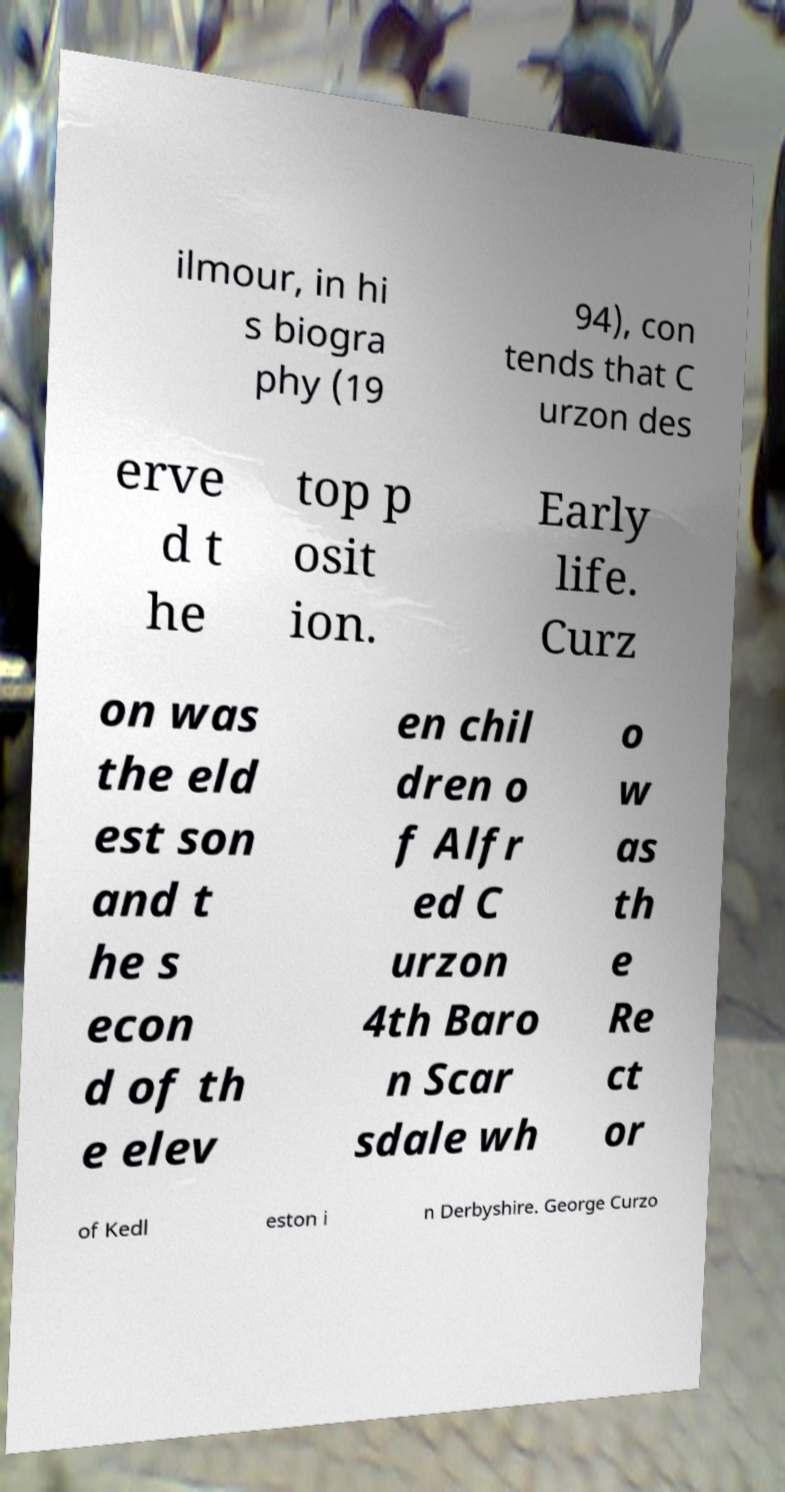Can you accurately transcribe the text from the provided image for me? ilmour, in hi s biogra phy (19 94), con tends that C urzon des erve d t he top p osit ion. Early life. Curz on was the eld est son and t he s econ d of th e elev en chil dren o f Alfr ed C urzon 4th Baro n Scar sdale wh o w as th e Re ct or of Kedl eston i n Derbyshire. George Curzo 